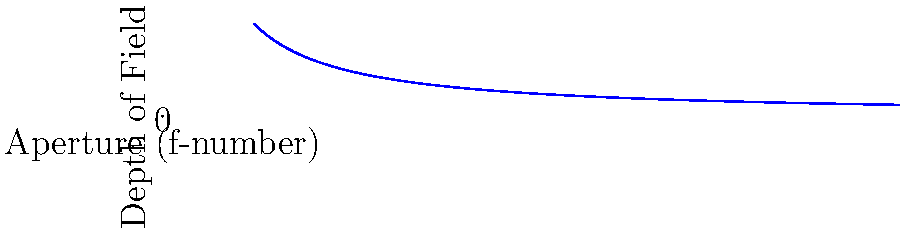As an aspiring photographer, you're experimenting with different aperture settings to control depth of field. Based on the graph, which shows the relationship between aperture (f-number) and depth of field, how does the depth of field change as you adjust your camera from f/2.8 to f/5.6? To answer this question, let's analyze the graph step-by-step:

1. The x-axis represents the aperture (f-number), while the y-axis represents the depth of field.

2. The curve shows an inverse relationship between aperture and depth of field. As the f-number increases, the depth of field increases.

3. Locate f/2.8 and f/5.6 on the x-axis:
   - f/2.8 is closer to the y-axis
   - f/5.6 is further to the right

4. Compare the corresponding y-values (depth of field) for these two points:
   - The y-value for f/2.8 is lower
   - The y-value for f/5.6 is higher

5. This indicates that as you move from f/2.8 to f/5.6, you're increasing the f-number and moving right on the x-axis.

6. Consequently, you're moving up the curve, which means the depth of field is increasing.

Therefore, when adjusting the camera from f/2.8 to f/5.6, the depth of field increases.
Answer: The depth of field increases. 